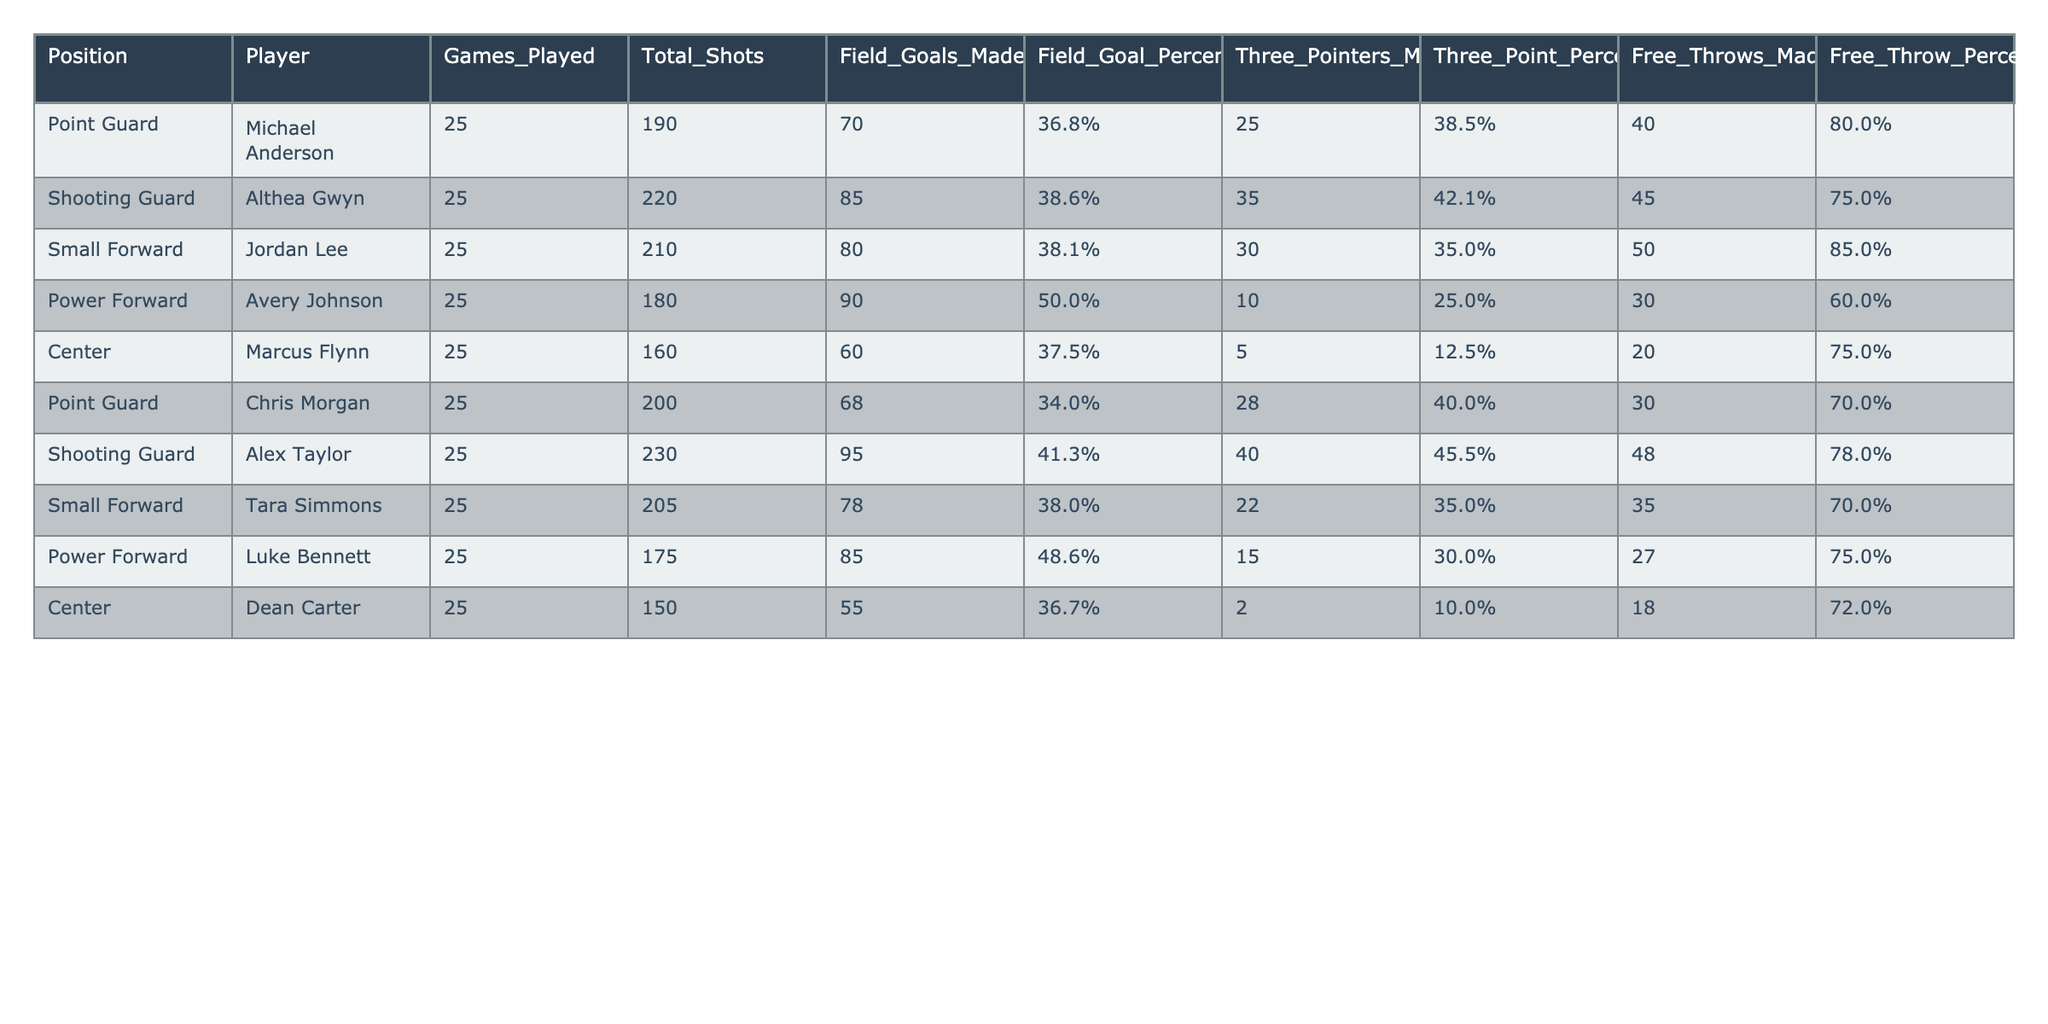What is Althea Gwyn's field goal percentage? According to the table, Althea Gwyn, who plays as a shooting guard, has a field goal percentage of 38.6%.
Answer: 38.6% How many total shots did Marcus Flynn make? The table indicates that Marcus Flynn made a total of 60 shots.
Answer: 60 Which player has the highest three-point percentage? By comparing the three-point percentages listed in the table, Alex Taylor has the highest at 45.5%.
Answer: 45.5% What is the average free throw percentage of players in the Power Forward position? The free throw percentages for Avery Johnson and Luke Bennett, the Power Forwards, are 60.0% and 75.0% respectively. The average is (60.0 + 75.0) / 2 = 67.5%.
Answer: 67.5% Did any player have a higher field goal percentage than 40%? Upon review, both Avery Johnson and Alex Taylor exceeded 40% in field goal percentage (50.0% and 41.3%, respectively). Therefore, the answer is yes.
Answer: Yes Which position had the lowest average points scored per game, assuming each field goal made is worth 2 points? Calculating points based on field goals made: Marcus Flynn (60*2 = 120), Chris Morgan (68*2 = 136), Althea Gwyn (85*2 = 170), etc. For each position, we can find the average. The Center position has the lowest average with 120 points over 25 games.
Answer: Center What is the difference in total shots taken between the Point Guards? Michael Anderson took 190 shots while Chris Morgan took 200 shots. The difference is 200 - 190 = 10.
Answer: 10 Which player has the highest total shots attempted? By inspecting the table, Alex Taylor made the highest number of total shots at 230.
Answer: 230 Is Avery Johnson's three-point percentage higher than that of Jordan Lee? Avery Johnson’s three-point percentage is 25.0%, while Jordan Lee’s is 35.0%. Therefore, Avery Johnson does not have a higher percentage.
Answer: No What is the total number of free throws made by all players combined? Summing the free throws made: 40 (Michael) + 45 (Althea) + 50 (Jordan) + 30 (Avery) + 20 (Marcus) + 30 (Chris) + 48 (Alex) + 35 (Tara) + 27 (Luke) + 18 (Dean) gives a total of 393 free throws made.
Answer: 393 